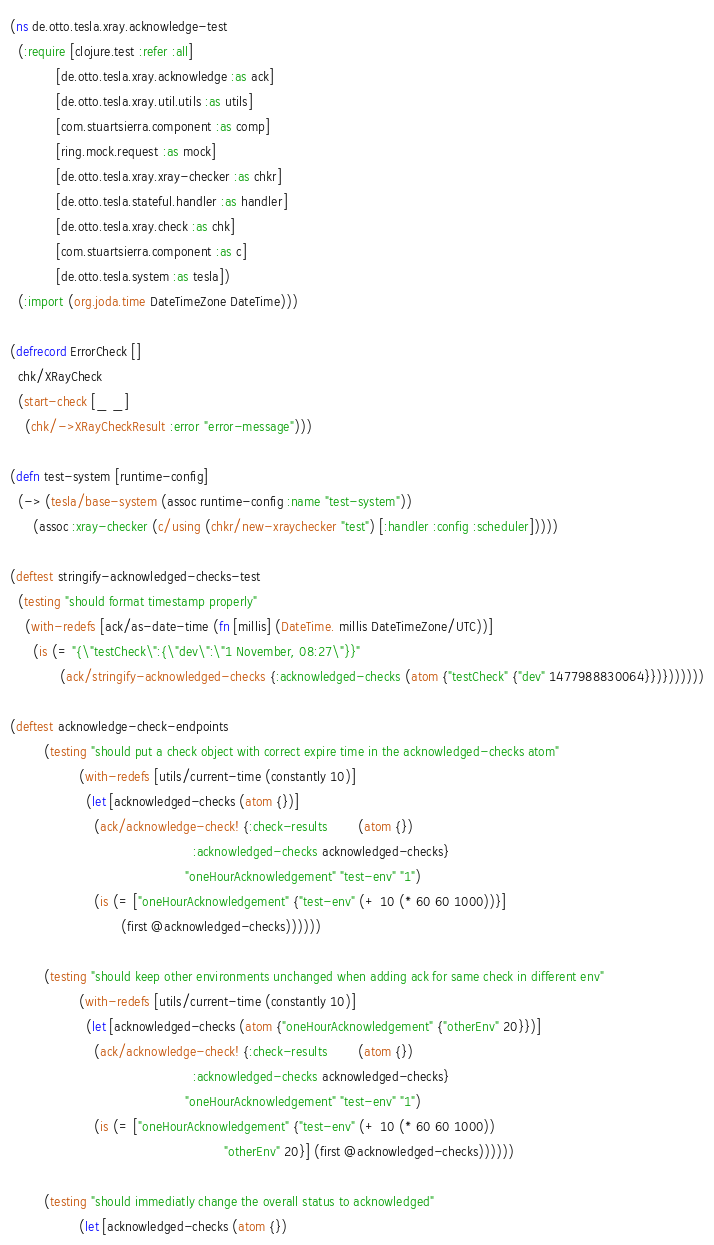<code> <loc_0><loc_0><loc_500><loc_500><_Clojure_>(ns de.otto.tesla.xray.acknowledge-test
  (:require [clojure.test :refer :all]
            [de.otto.tesla.xray.acknowledge :as ack]
            [de.otto.tesla.xray.util.utils :as utils]
            [com.stuartsierra.component :as comp]
            [ring.mock.request :as mock]
            [de.otto.tesla.xray.xray-checker :as chkr]
            [de.otto.tesla.stateful.handler :as handler]
            [de.otto.tesla.xray.check :as chk]
            [com.stuartsierra.component :as c]
            [de.otto.tesla.system :as tesla])
  (:import (org.joda.time DateTimeZone DateTime)))

(defrecord ErrorCheck []
  chk/XRayCheck
  (start-check [_ _]
    (chk/->XRayCheckResult :error "error-message")))

(defn test-system [runtime-config]
  (-> (tesla/base-system (assoc runtime-config :name "test-system"))
      (assoc :xray-checker (c/using (chkr/new-xraychecker "test") [:handler :config :scheduler]))))

(deftest stringify-acknowledged-checks-test
  (testing "should format timestamp properly"
    (with-redefs [ack/as-date-time (fn [millis] (DateTime. millis DateTimeZone/UTC))]
      (is (= "{\"testCheck\":{\"dev\":\"1 November, 08:27\"}}"
             (ack/stringify-acknowledged-checks {:acknowledged-checks (atom {"testCheck" {"dev" 1477988830064}})}))))))

(deftest acknowledge-check-endpoints
         (testing "should put a check object with correct expire time in the acknowledged-checks atom"
                  (with-redefs [utils/current-time (constantly 10)]
                    (let [acknowledged-checks (atom {})]
                      (ack/acknowledge-check! {:check-results        (atom {})
                                                :acknowledged-checks acknowledged-checks}
                                              "oneHourAcknowledgement" "test-env" "1")
                      (is (= ["oneHourAcknowledgement" {"test-env" (+ 10 (* 60 60 1000))}]
                             (first @acknowledged-checks))))))

         (testing "should keep other environments unchanged when adding ack for same check in different env"
                  (with-redefs [utils/current-time (constantly 10)]
                    (let [acknowledged-checks (atom {"oneHourAcknowledgement" {"otherEnv" 20}})]
                      (ack/acknowledge-check! {:check-results        (atom {})
                                                :acknowledged-checks acknowledged-checks}
                                              "oneHourAcknowledgement" "test-env" "1")
                      (is (= ["oneHourAcknowledgement" {"test-env" (+ 10 (* 60 60 1000))
                                                        "otherEnv" 20}] (first @acknowledged-checks))))))

         (testing "should immediatly change the overall status to acknowledged"
                  (let [acknowledged-checks (atom {})</code> 